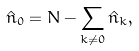<formula> <loc_0><loc_0><loc_500><loc_500>\hat { n } _ { 0 } = N - \sum _ { k \neq 0 } \hat { n } _ { k } ,</formula> 